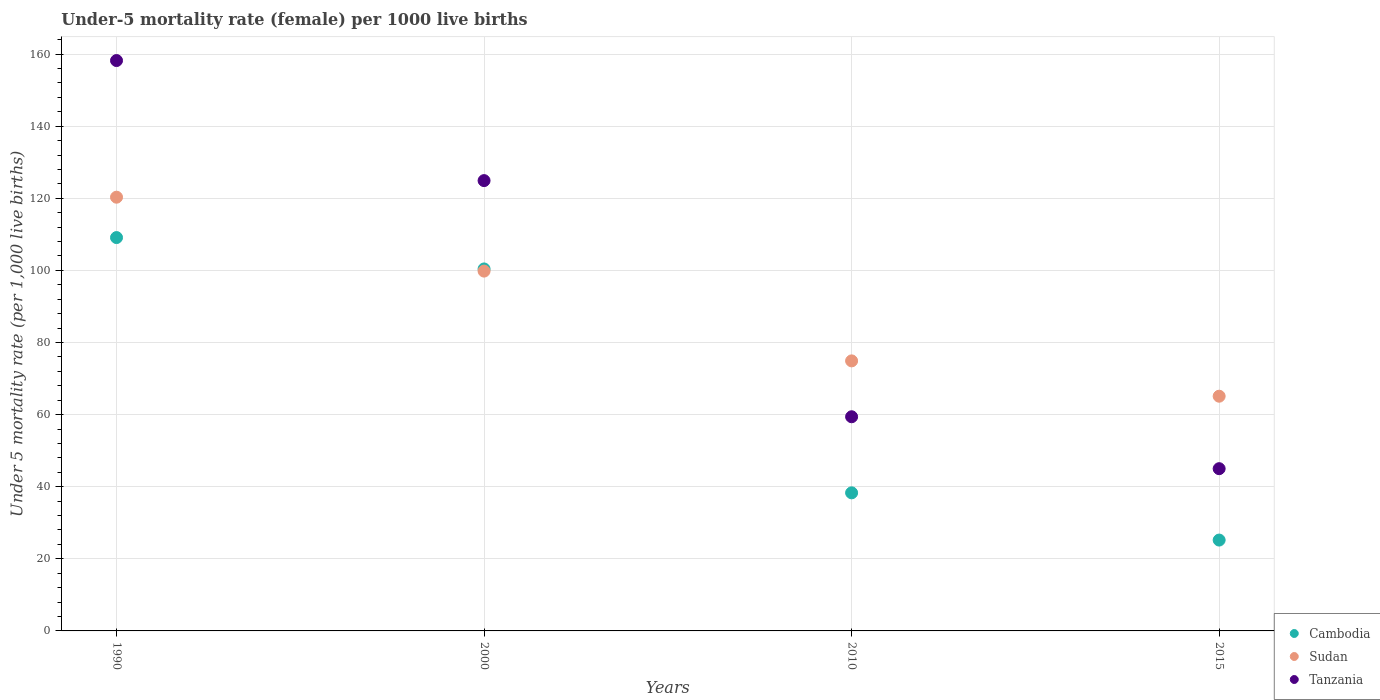How many different coloured dotlines are there?
Keep it short and to the point. 3. Is the number of dotlines equal to the number of legend labels?
Offer a very short reply. Yes. What is the under-five mortality rate in Tanzania in 1990?
Make the answer very short. 158.2. Across all years, what is the maximum under-five mortality rate in Sudan?
Your answer should be very brief. 120.3. In which year was the under-five mortality rate in Cambodia maximum?
Give a very brief answer. 1990. In which year was the under-five mortality rate in Tanzania minimum?
Offer a very short reply. 2015. What is the total under-five mortality rate in Sudan in the graph?
Make the answer very short. 360.1. What is the difference between the under-five mortality rate in Tanzania in 2010 and that in 2015?
Make the answer very short. 14.4. What is the difference between the under-five mortality rate in Cambodia in 2015 and the under-five mortality rate in Sudan in 1990?
Offer a very short reply. -95.1. What is the average under-five mortality rate in Cambodia per year?
Ensure brevity in your answer.  68.25. In the year 2010, what is the difference between the under-five mortality rate in Sudan and under-five mortality rate in Cambodia?
Your answer should be compact. 36.6. In how many years, is the under-five mortality rate in Tanzania greater than 152?
Offer a terse response. 1. What is the ratio of the under-five mortality rate in Cambodia in 2000 to that in 2015?
Give a very brief answer. 3.98. Is the under-five mortality rate in Sudan in 1990 less than that in 2000?
Your answer should be very brief. No. Is the difference between the under-five mortality rate in Sudan in 2010 and 2015 greater than the difference between the under-five mortality rate in Cambodia in 2010 and 2015?
Provide a succinct answer. No. What is the difference between the highest and the second highest under-five mortality rate in Tanzania?
Provide a short and direct response. 33.3. What is the difference between the highest and the lowest under-five mortality rate in Sudan?
Offer a terse response. 55.2. Is the sum of the under-five mortality rate in Tanzania in 2010 and 2015 greater than the maximum under-five mortality rate in Cambodia across all years?
Offer a terse response. No. Is it the case that in every year, the sum of the under-five mortality rate in Sudan and under-five mortality rate in Cambodia  is greater than the under-five mortality rate in Tanzania?
Ensure brevity in your answer.  Yes. Is the under-five mortality rate in Tanzania strictly greater than the under-five mortality rate in Sudan over the years?
Your response must be concise. No. How many dotlines are there?
Make the answer very short. 3. What is the difference between two consecutive major ticks on the Y-axis?
Offer a very short reply. 20. Are the values on the major ticks of Y-axis written in scientific E-notation?
Make the answer very short. No. Does the graph contain grids?
Give a very brief answer. Yes. How are the legend labels stacked?
Give a very brief answer. Vertical. What is the title of the graph?
Your answer should be very brief. Under-5 mortality rate (female) per 1000 live births. What is the label or title of the X-axis?
Your response must be concise. Years. What is the label or title of the Y-axis?
Ensure brevity in your answer.  Under 5 mortality rate (per 1,0 live births). What is the Under 5 mortality rate (per 1,000 live births) in Cambodia in 1990?
Offer a terse response. 109.1. What is the Under 5 mortality rate (per 1,000 live births) of Sudan in 1990?
Your answer should be compact. 120.3. What is the Under 5 mortality rate (per 1,000 live births) of Tanzania in 1990?
Provide a succinct answer. 158.2. What is the Under 5 mortality rate (per 1,000 live births) in Cambodia in 2000?
Give a very brief answer. 100.4. What is the Under 5 mortality rate (per 1,000 live births) in Sudan in 2000?
Make the answer very short. 99.8. What is the Under 5 mortality rate (per 1,000 live births) of Tanzania in 2000?
Give a very brief answer. 124.9. What is the Under 5 mortality rate (per 1,000 live births) in Cambodia in 2010?
Give a very brief answer. 38.3. What is the Under 5 mortality rate (per 1,000 live births) of Sudan in 2010?
Your answer should be very brief. 74.9. What is the Under 5 mortality rate (per 1,000 live births) of Tanzania in 2010?
Your answer should be very brief. 59.4. What is the Under 5 mortality rate (per 1,000 live births) in Cambodia in 2015?
Your answer should be compact. 25.2. What is the Under 5 mortality rate (per 1,000 live births) of Sudan in 2015?
Provide a short and direct response. 65.1. What is the Under 5 mortality rate (per 1,000 live births) of Tanzania in 2015?
Your answer should be very brief. 45. Across all years, what is the maximum Under 5 mortality rate (per 1,000 live births) of Cambodia?
Provide a short and direct response. 109.1. Across all years, what is the maximum Under 5 mortality rate (per 1,000 live births) in Sudan?
Your answer should be very brief. 120.3. Across all years, what is the maximum Under 5 mortality rate (per 1,000 live births) in Tanzania?
Ensure brevity in your answer.  158.2. Across all years, what is the minimum Under 5 mortality rate (per 1,000 live births) of Cambodia?
Your response must be concise. 25.2. Across all years, what is the minimum Under 5 mortality rate (per 1,000 live births) in Sudan?
Give a very brief answer. 65.1. What is the total Under 5 mortality rate (per 1,000 live births) of Cambodia in the graph?
Your response must be concise. 273. What is the total Under 5 mortality rate (per 1,000 live births) in Sudan in the graph?
Ensure brevity in your answer.  360.1. What is the total Under 5 mortality rate (per 1,000 live births) of Tanzania in the graph?
Ensure brevity in your answer.  387.5. What is the difference between the Under 5 mortality rate (per 1,000 live births) of Tanzania in 1990 and that in 2000?
Your answer should be compact. 33.3. What is the difference between the Under 5 mortality rate (per 1,000 live births) of Cambodia in 1990 and that in 2010?
Offer a very short reply. 70.8. What is the difference between the Under 5 mortality rate (per 1,000 live births) in Sudan in 1990 and that in 2010?
Your answer should be compact. 45.4. What is the difference between the Under 5 mortality rate (per 1,000 live births) of Tanzania in 1990 and that in 2010?
Offer a very short reply. 98.8. What is the difference between the Under 5 mortality rate (per 1,000 live births) of Cambodia in 1990 and that in 2015?
Your answer should be compact. 83.9. What is the difference between the Under 5 mortality rate (per 1,000 live births) of Sudan in 1990 and that in 2015?
Your answer should be compact. 55.2. What is the difference between the Under 5 mortality rate (per 1,000 live births) in Tanzania in 1990 and that in 2015?
Your answer should be compact. 113.2. What is the difference between the Under 5 mortality rate (per 1,000 live births) in Cambodia in 2000 and that in 2010?
Offer a very short reply. 62.1. What is the difference between the Under 5 mortality rate (per 1,000 live births) of Sudan in 2000 and that in 2010?
Provide a short and direct response. 24.9. What is the difference between the Under 5 mortality rate (per 1,000 live births) of Tanzania in 2000 and that in 2010?
Make the answer very short. 65.5. What is the difference between the Under 5 mortality rate (per 1,000 live births) of Cambodia in 2000 and that in 2015?
Your response must be concise. 75.2. What is the difference between the Under 5 mortality rate (per 1,000 live births) of Sudan in 2000 and that in 2015?
Your answer should be very brief. 34.7. What is the difference between the Under 5 mortality rate (per 1,000 live births) of Tanzania in 2000 and that in 2015?
Ensure brevity in your answer.  79.9. What is the difference between the Under 5 mortality rate (per 1,000 live births) in Cambodia in 2010 and that in 2015?
Your answer should be very brief. 13.1. What is the difference between the Under 5 mortality rate (per 1,000 live births) in Sudan in 2010 and that in 2015?
Give a very brief answer. 9.8. What is the difference between the Under 5 mortality rate (per 1,000 live births) in Tanzania in 2010 and that in 2015?
Offer a terse response. 14.4. What is the difference between the Under 5 mortality rate (per 1,000 live births) in Cambodia in 1990 and the Under 5 mortality rate (per 1,000 live births) in Sudan in 2000?
Make the answer very short. 9.3. What is the difference between the Under 5 mortality rate (per 1,000 live births) of Cambodia in 1990 and the Under 5 mortality rate (per 1,000 live births) of Tanzania in 2000?
Keep it short and to the point. -15.8. What is the difference between the Under 5 mortality rate (per 1,000 live births) of Sudan in 1990 and the Under 5 mortality rate (per 1,000 live births) of Tanzania in 2000?
Your answer should be very brief. -4.6. What is the difference between the Under 5 mortality rate (per 1,000 live births) in Cambodia in 1990 and the Under 5 mortality rate (per 1,000 live births) in Sudan in 2010?
Give a very brief answer. 34.2. What is the difference between the Under 5 mortality rate (per 1,000 live births) of Cambodia in 1990 and the Under 5 mortality rate (per 1,000 live births) of Tanzania in 2010?
Offer a very short reply. 49.7. What is the difference between the Under 5 mortality rate (per 1,000 live births) of Sudan in 1990 and the Under 5 mortality rate (per 1,000 live births) of Tanzania in 2010?
Your response must be concise. 60.9. What is the difference between the Under 5 mortality rate (per 1,000 live births) in Cambodia in 1990 and the Under 5 mortality rate (per 1,000 live births) in Sudan in 2015?
Your answer should be very brief. 44. What is the difference between the Under 5 mortality rate (per 1,000 live births) in Cambodia in 1990 and the Under 5 mortality rate (per 1,000 live births) in Tanzania in 2015?
Ensure brevity in your answer.  64.1. What is the difference between the Under 5 mortality rate (per 1,000 live births) of Sudan in 1990 and the Under 5 mortality rate (per 1,000 live births) of Tanzania in 2015?
Offer a very short reply. 75.3. What is the difference between the Under 5 mortality rate (per 1,000 live births) in Cambodia in 2000 and the Under 5 mortality rate (per 1,000 live births) in Tanzania in 2010?
Ensure brevity in your answer.  41. What is the difference between the Under 5 mortality rate (per 1,000 live births) in Sudan in 2000 and the Under 5 mortality rate (per 1,000 live births) in Tanzania in 2010?
Ensure brevity in your answer.  40.4. What is the difference between the Under 5 mortality rate (per 1,000 live births) in Cambodia in 2000 and the Under 5 mortality rate (per 1,000 live births) in Sudan in 2015?
Offer a very short reply. 35.3. What is the difference between the Under 5 mortality rate (per 1,000 live births) of Cambodia in 2000 and the Under 5 mortality rate (per 1,000 live births) of Tanzania in 2015?
Your answer should be very brief. 55.4. What is the difference between the Under 5 mortality rate (per 1,000 live births) in Sudan in 2000 and the Under 5 mortality rate (per 1,000 live births) in Tanzania in 2015?
Your answer should be compact. 54.8. What is the difference between the Under 5 mortality rate (per 1,000 live births) of Cambodia in 2010 and the Under 5 mortality rate (per 1,000 live births) of Sudan in 2015?
Provide a succinct answer. -26.8. What is the difference between the Under 5 mortality rate (per 1,000 live births) in Sudan in 2010 and the Under 5 mortality rate (per 1,000 live births) in Tanzania in 2015?
Provide a succinct answer. 29.9. What is the average Under 5 mortality rate (per 1,000 live births) of Cambodia per year?
Your response must be concise. 68.25. What is the average Under 5 mortality rate (per 1,000 live births) of Sudan per year?
Make the answer very short. 90.03. What is the average Under 5 mortality rate (per 1,000 live births) of Tanzania per year?
Make the answer very short. 96.88. In the year 1990, what is the difference between the Under 5 mortality rate (per 1,000 live births) in Cambodia and Under 5 mortality rate (per 1,000 live births) in Tanzania?
Keep it short and to the point. -49.1. In the year 1990, what is the difference between the Under 5 mortality rate (per 1,000 live births) of Sudan and Under 5 mortality rate (per 1,000 live births) of Tanzania?
Offer a very short reply. -37.9. In the year 2000, what is the difference between the Under 5 mortality rate (per 1,000 live births) of Cambodia and Under 5 mortality rate (per 1,000 live births) of Tanzania?
Provide a short and direct response. -24.5. In the year 2000, what is the difference between the Under 5 mortality rate (per 1,000 live births) of Sudan and Under 5 mortality rate (per 1,000 live births) of Tanzania?
Ensure brevity in your answer.  -25.1. In the year 2010, what is the difference between the Under 5 mortality rate (per 1,000 live births) in Cambodia and Under 5 mortality rate (per 1,000 live births) in Sudan?
Give a very brief answer. -36.6. In the year 2010, what is the difference between the Under 5 mortality rate (per 1,000 live births) of Cambodia and Under 5 mortality rate (per 1,000 live births) of Tanzania?
Offer a terse response. -21.1. In the year 2015, what is the difference between the Under 5 mortality rate (per 1,000 live births) in Cambodia and Under 5 mortality rate (per 1,000 live births) in Sudan?
Ensure brevity in your answer.  -39.9. In the year 2015, what is the difference between the Under 5 mortality rate (per 1,000 live births) in Cambodia and Under 5 mortality rate (per 1,000 live births) in Tanzania?
Your answer should be compact. -19.8. In the year 2015, what is the difference between the Under 5 mortality rate (per 1,000 live births) of Sudan and Under 5 mortality rate (per 1,000 live births) of Tanzania?
Offer a terse response. 20.1. What is the ratio of the Under 5 mortality rate (per 1,000 live births) in Cambodia in 1990 to that in 2000?
Your answer should be very brief. 1.09. What is the ratio of the Under 5 mortality rate (per 1,000 live births) in Sudan in 1990 to that in 2000?
Make the answer very short. 1.21. What is the ratio of the Under 5 mortality rate (per 1,000 live births) of Tanzania in 1990 to that in 2000?
Offer a very short reply. 1.27. What is the ratio of the Under 5 mortality rate (per 1,000 live births) of Cambodia in 1990 to that in 2010?
Provide a succinct answer. 2.85. What is the ratio of the Under 5 mortality rate (per 1,000 live births) of Sudan in 1990 to that in 2010?
Your response must be concise. 1.61. What is the ratio of the Under 5 mortality rate (per 1,000 live births) of Tanzania in 1990 to that in 2010?
Ensure brevity in your answer.  2.66. What is the ratio of the Under 5 mortality rate (per 1,000 live births) of Cambodia in 1990 to that in 2015?
Ensure brevity in your answer.  4.33. What is the ratio of the Under 5 mortality rate (per 1,000 live births) in Sudan in 1990 to that in 2015?
Offer a very short reply. 1.85. What is the ratio of the Under 5 mortality rate (per 1,000 live births) of Tanzania in 1990 to that in 2015?
Offer a very short reply. 3.52. What is the ratio of the Under 5 mortality rate (per 1,000 live births) in Cambodia in 2000 to that in 2010?
Provide a succinct answer. 2.62. What is the ratio of the Under 5 mortality rate (per 1,000 live births) of Sudan in 2000 to that in 2010?
Offer a terse response. 1.33. What is the ratio of the Under 5 mortality rate (per 1,000 live births) in Tanzania in 2000 to that in 2010?
Your answer should be compact. 2.1. What is the ratio of the Under 5 mortality rate (per 1,000 live births) of Cambodia in 2000 to that in 2015?
Your response must be concise. 3.98. What is the ratio of the Under 5 mortality rate (per 1,000 live births) in Sudan in 2000 to that in 2015?
Your response must be concise. 1.53. What is the ratio of the Under 5 mortality rate (per 1,000 live births) in Tanzania in 2000 to that in 2015?
Make the answer very short. 2.78. What is the ratio of the Under 5 mortality rate (per 1,000 live births) of Cambodia in 2010 to that in 2015?
Your answer should be compact. 1.52. What is the ratio of the Under 5 mortality rate (per 1,000 live births) in Sudan in 2010 to that in 2015?
Give a very brief answer. 1.15. What is the ratio of the Under 5 mortality rate (per 1,000 live births) in Tanzania in 2010 to that in 2015?
Your answer should be compact. 1.32. What is the difference between the highest and the second highest Under 5 mortality rate (per 1,000 live births) of Tanzania?
Your answer should be very brief. 33.3. What is the difference between the highest and the lowest Under 5 mortality rate (per 1,000 live births) in Cambodia?
Offer a terse response. 83.9. What is the difference between the highest and the lowest Under 5 mortality rate (per 1,000 live births) of Sudan?
Give a very brief answer. 55.2. What is the difference between the highest and the lowest Under 5 mortality rate (per 1,000 live births) in Tanzania?
Your answer should be very brief. 113.2. 